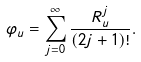<formula> <loc_0><loc_0><loc_500><loc_500>\varphi _ { u } = \sum _ { j = 0 } ^ { \infty } \frac { R _ { u } ^ { j } } { ( 2 j + 1 ) ! } .</formula> 